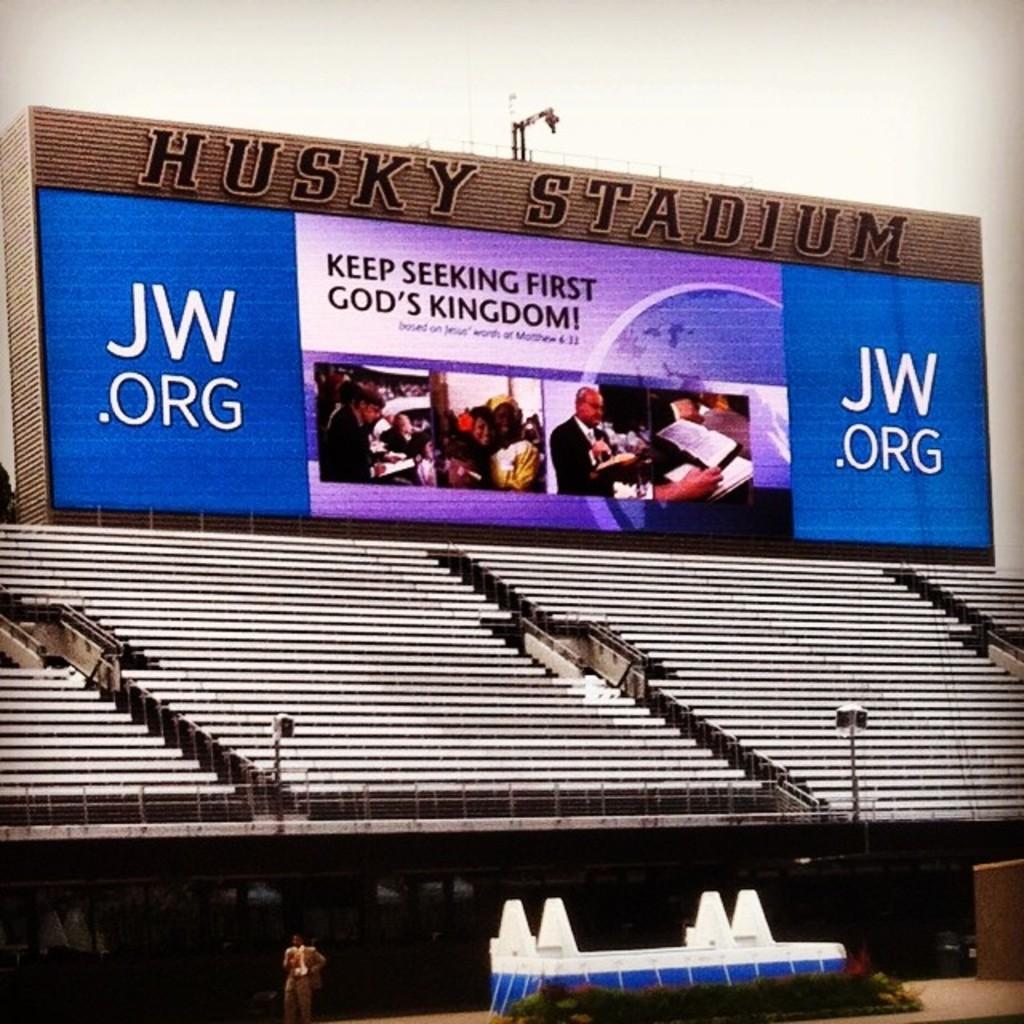What website is show on the board?
Make the answer very short. Jw.org. 